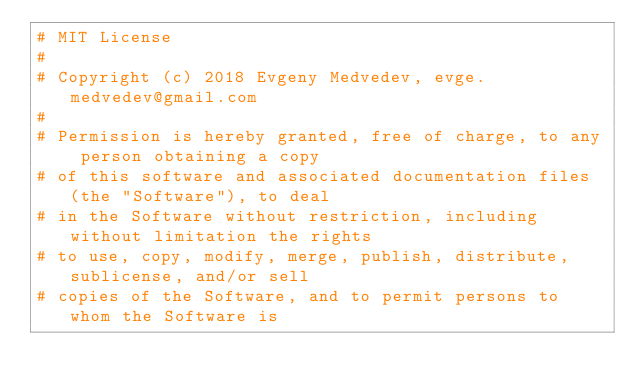<code> <loc_0><loc_0><loc_500><loc_500><_Python_># MIT License
#
# Copyright (c) 2018 Evgeny Medvedev, evge.medvedev@gmail.com
#
# Permission is hereby granted, free of charge, to any person obtaining a copy
# of this software and associated documentation files (the "Software"), to deal
# in the Software without restriction, including without limitation the rights
# to use, copy, modify, merge, publish, distribute, sublicense, and/or sell
# copies of the Software, and to permit persons to whom the Software is</code> 